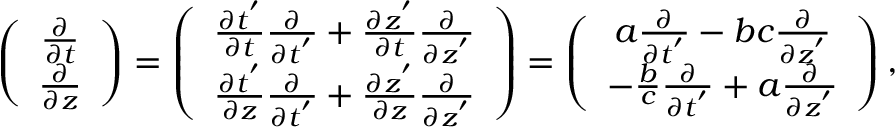<formula> <loc_0><loc_0><loc_500><loc_500>\begin{array} { r } { \left ( \begin{array} { c } { \frac { \partial } { \partial t } } \\ { \frac { \partial } { \partial z } } \end{array} \right ) = \left ( \begin{array} { c } { \frac { \partial t ^ { ^ { \prime } } } { \partial t } \frac { \partial } { \partial t ^ { ^ { \prime } } } + \frac { \partial z ^ { ^ { \prime } } } { \partial t } \frac { \partial } { \partial z ^ { ^ { \prime } } } } \\ { \frac { \partial t ^ { ^ { \prime } } } { \partial z } \frac { \partial } { \partial t ^ { ^ { \prime } } } + \frac { \partial z ^ { ^ { \prime } } } { \partial z } \frac { \partial } { \partial z ^ { ^ { \prime } } } } \end{array} \right ) = \left ( \begin{array} { c } { a \frac { \partial } { \partial t ^ { ^ { \prime } } } - b c \frac { \partial } { \partial z ^ { ^ { \prime } } } } \\ { - \frac { b } { c } \frac { \partial } { \partial t ^ { ^ { \prime } } } + a \frac { \partial } { \partial z ^ { ^ { \prime } } } } \end{array} \right ) , } \end{array}</formula> 